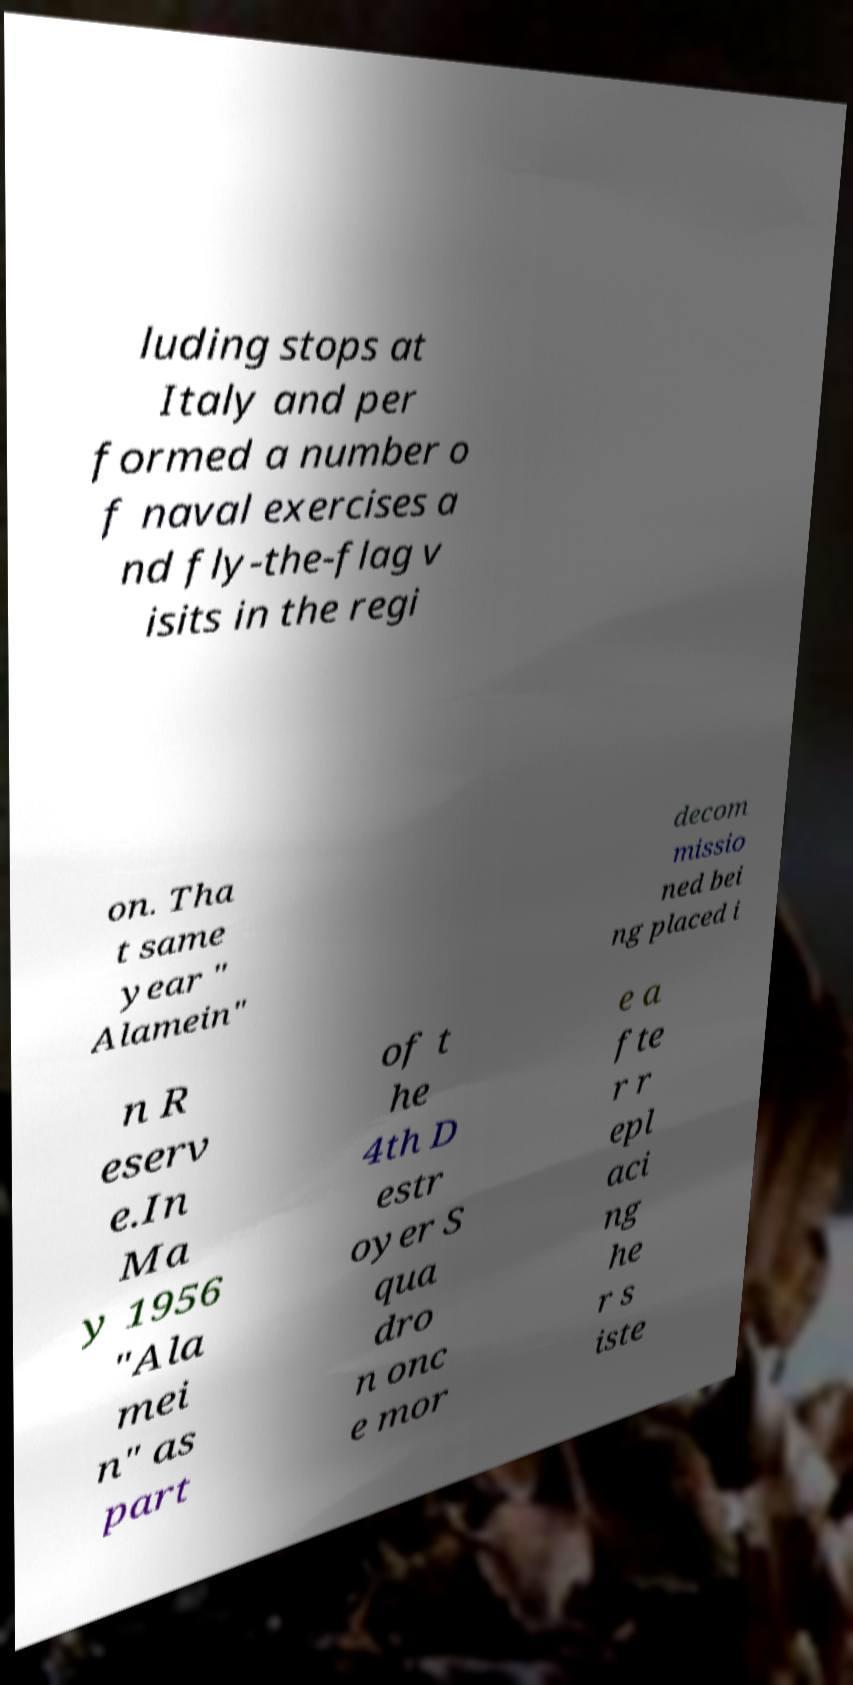Please identify and transcribe the text found in this image. luding stops at Italy and per formed a number o f naval exercises a nd fly-the-flag v isits in the regi on. Tha t same year " Alamein" decom missio ned bei ng placed i n R eserv e.In Ma y 1956 "Ala mei n" as part of t he 4th D estr oyer S qua dro n onc e mor e a fte r r epl aci ng he r s iste 